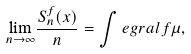Convert formula to latex. <formula><loc_0><loc_0><loc_500><loc_500>\underset { n \rightarrow \infty } { \lim } \frac { S _ { n } ^ { f } ( x ) } { n } = \int e g r a l { f } { \mu } ,</formula> 